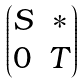Convert formula to latex. <formula><loc_0><loc_0><loc_500><loc_500>\begin{pmatrix} S & \ast \\ 0 & T \end{pmatrix}</formula> 